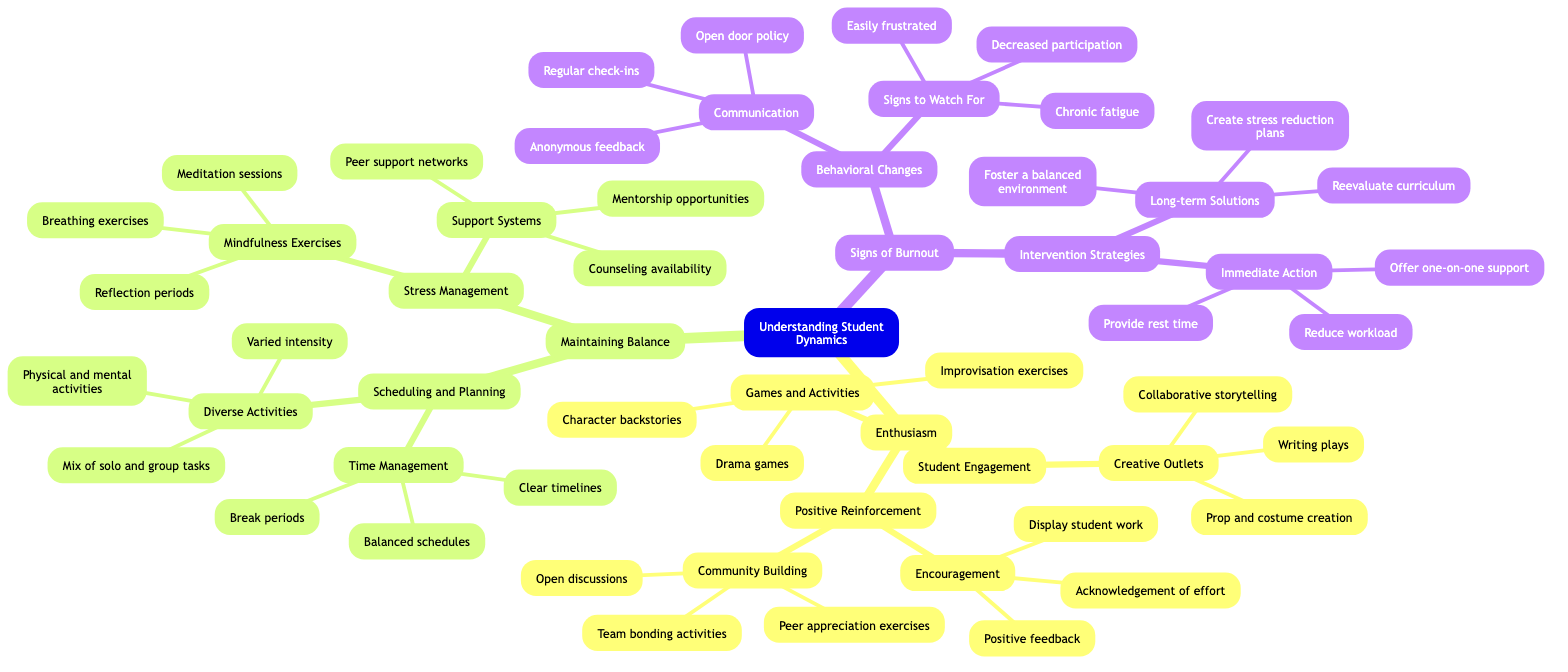What are the two main categories in the diagram? The diagram shows two main categories, "Enthusiasm" and "Maintaining Balance." These are the primary nodes under the central theme "Understanding Student Dynamics."
Answer: Enthusiasm, Maintaining Balance How many activities fall under "Games and Activities"? Under "Games and Activities," there are three listed activities: "Improvisation exercises," "Drama games," and "Character backstories." Therefore, the total count is three.
Answer: 3 What is included in "Support Systems"? "Support Systems" includes three components: "Mentorship opportunities," "Counseling availability," and "Peer support networks." These are specified as measures to help manage stress.
Answer: Mentorship opportunities, Counseling availability, Peer support networks What should be done immediately when signs of burnout are detected? The diagram specifies three immediate actions: "Provide rest time," "Reduce workload," and "Offer one-on-one support." Therefore, any of these three actions should be taken quickly.
Answer: Provide rest time What are the signs of burnout listed under "Behavioral Changes"? The signs of burnout mentioned are "Decreased participation," "Chronic fatigue," and "Easily frustrated.” Hence, the answer includes all these symptoms as indicators.
Answer: Decreased participation, Chronic fatigue, Easily frustrated Which section focuses on student engagement? The section titled "Student Engagement" is under the category "Enthusiasm." This section directly pertains to how students are engaged and participate in activities.
Answer: Student Engagement What is one recommended strategy to maintain balance? One of the recommended strategies to maintain balance is "Mindfulness Exercises," which includes practices like "Breathing exercises" and "Meditation sessions." This aims to help students manage their mental well-being.
Answer: Mindfulness Exercises How many total nodes are there under "Positive Reinforcement"? Under "Positive Reinforcement," there are two main subcategories: "Encouragement" and "Community Building." Each of those categories has three associated items, making a total of six nodes in this section.
Answer: 6 What technique is suggested for stress management? The diagram suggests "Breathing exercises" as a technique included in the "Mindfulness Exercises" section for managing stress. This implies using breathing techniques to help alleviate stress levels.
Answer: Breathing exercises 